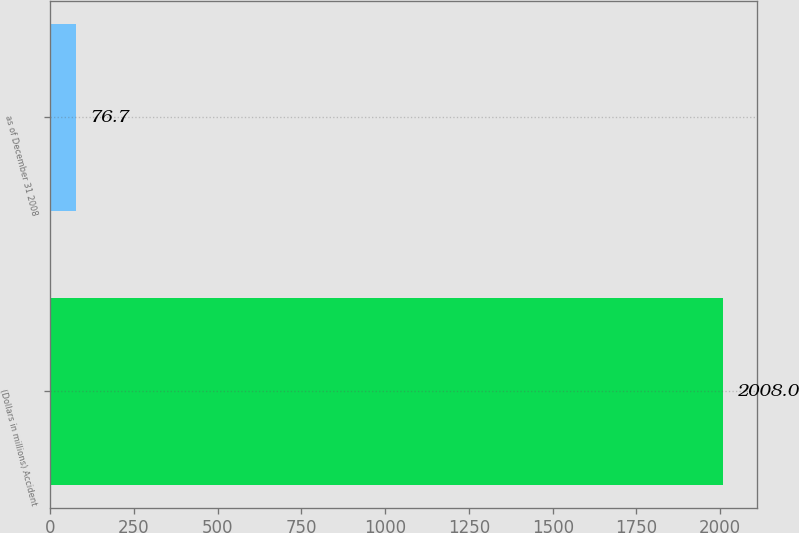Convert chart to OTSL. <chart><loc_0><loc_0><loc_500><loc_500><bar_chart><fcel>(Dollars in millions) Accident<fcel>as of December 31 2008<nl><fcel>2008<fcel>76.7<nl></chart> 